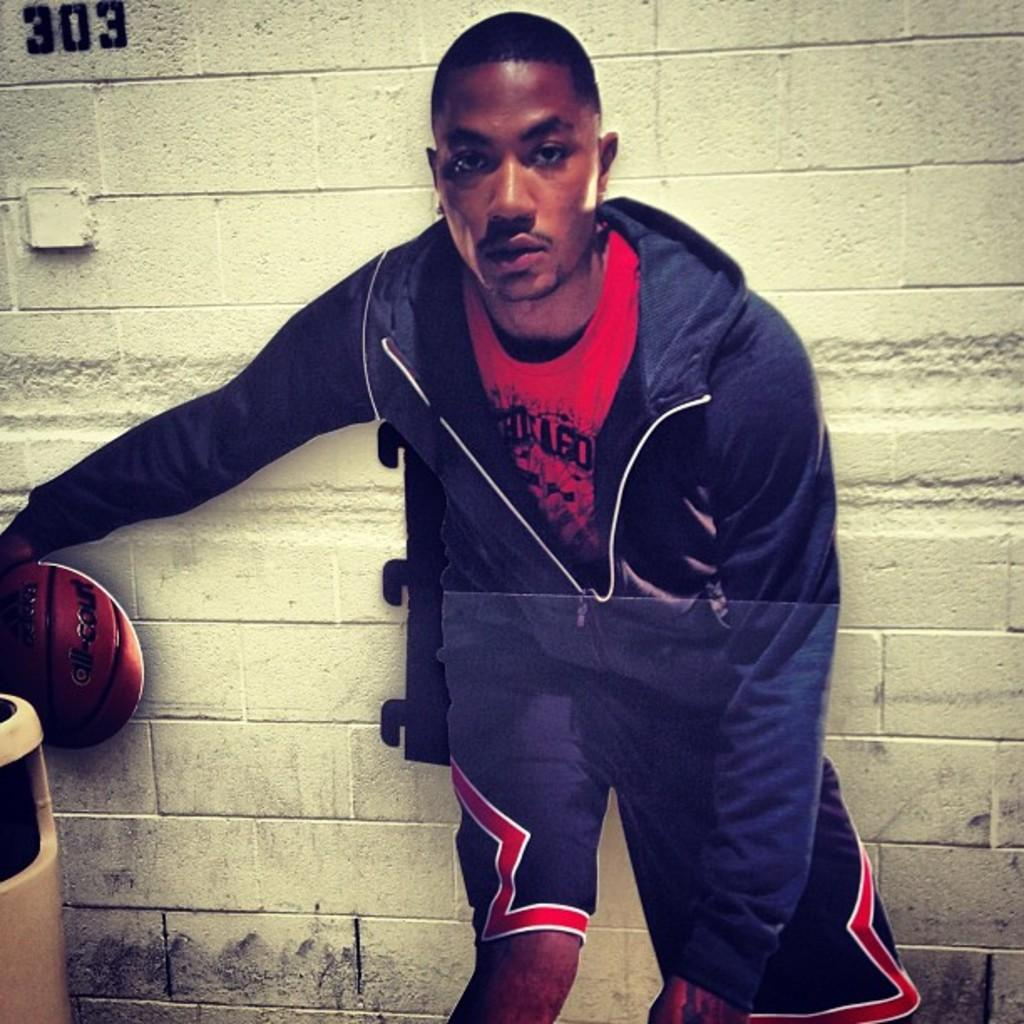<image>
Create a compact narrative representing the image presented. A young man stands in front of a wall with 303 painted on the upper left corner. 